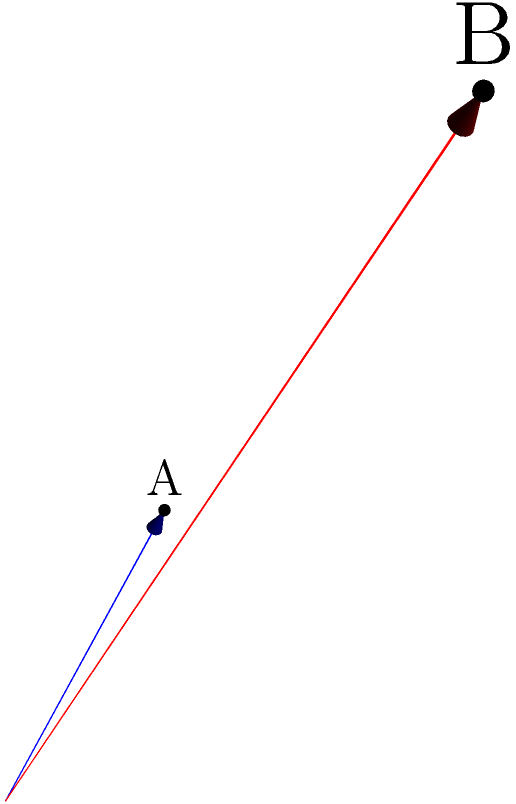В трехмерном пространстве даны два вектора: $\mathbf{a} = (1, 2, 3)$ и $\mathbf{b} = (4, 5, 6)$. Вычислите скалярное произведение этих векторов. Для вычисления скалярного произведения двух векторов в трехмерном пространстве используем формулу:

$$\mathbf{a} \cdot \mathbf{b} = a_x b_x + a_y b_y + a_z b_z$$

где $a_x, a_y, a_z$ - компоненты вектора $\mathbf{a}$, а $b_x, b_y, b_z$ - компоненты вектора $\mathbf{b}$.

Подставляем значения:

1) $a_x b_x = 1 \cdot 4 = 4$
2) $a_y b_y = 2 \cdot 5 = 10$
3) $a_z b_z = 3 \cdot 6 = 18$

Суммируем результаты:

$$\mathbf{a} \cdot \mathbf{b} = 4 + 10 + 18 = 32$$

Таким образом, скалярное произведение векторов $\mathbf{a}$ и $\mathbf{b}$ равно 32.
Answer: 32 